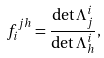<formula> <loc_0><loc_0><loc_500><loc_500>f ^ { j h } _ { i } = \frac { \det \Lambda _ { j } ^ { i } } { \det \Lambda _ { h } ^ { i } } ,</formula> 